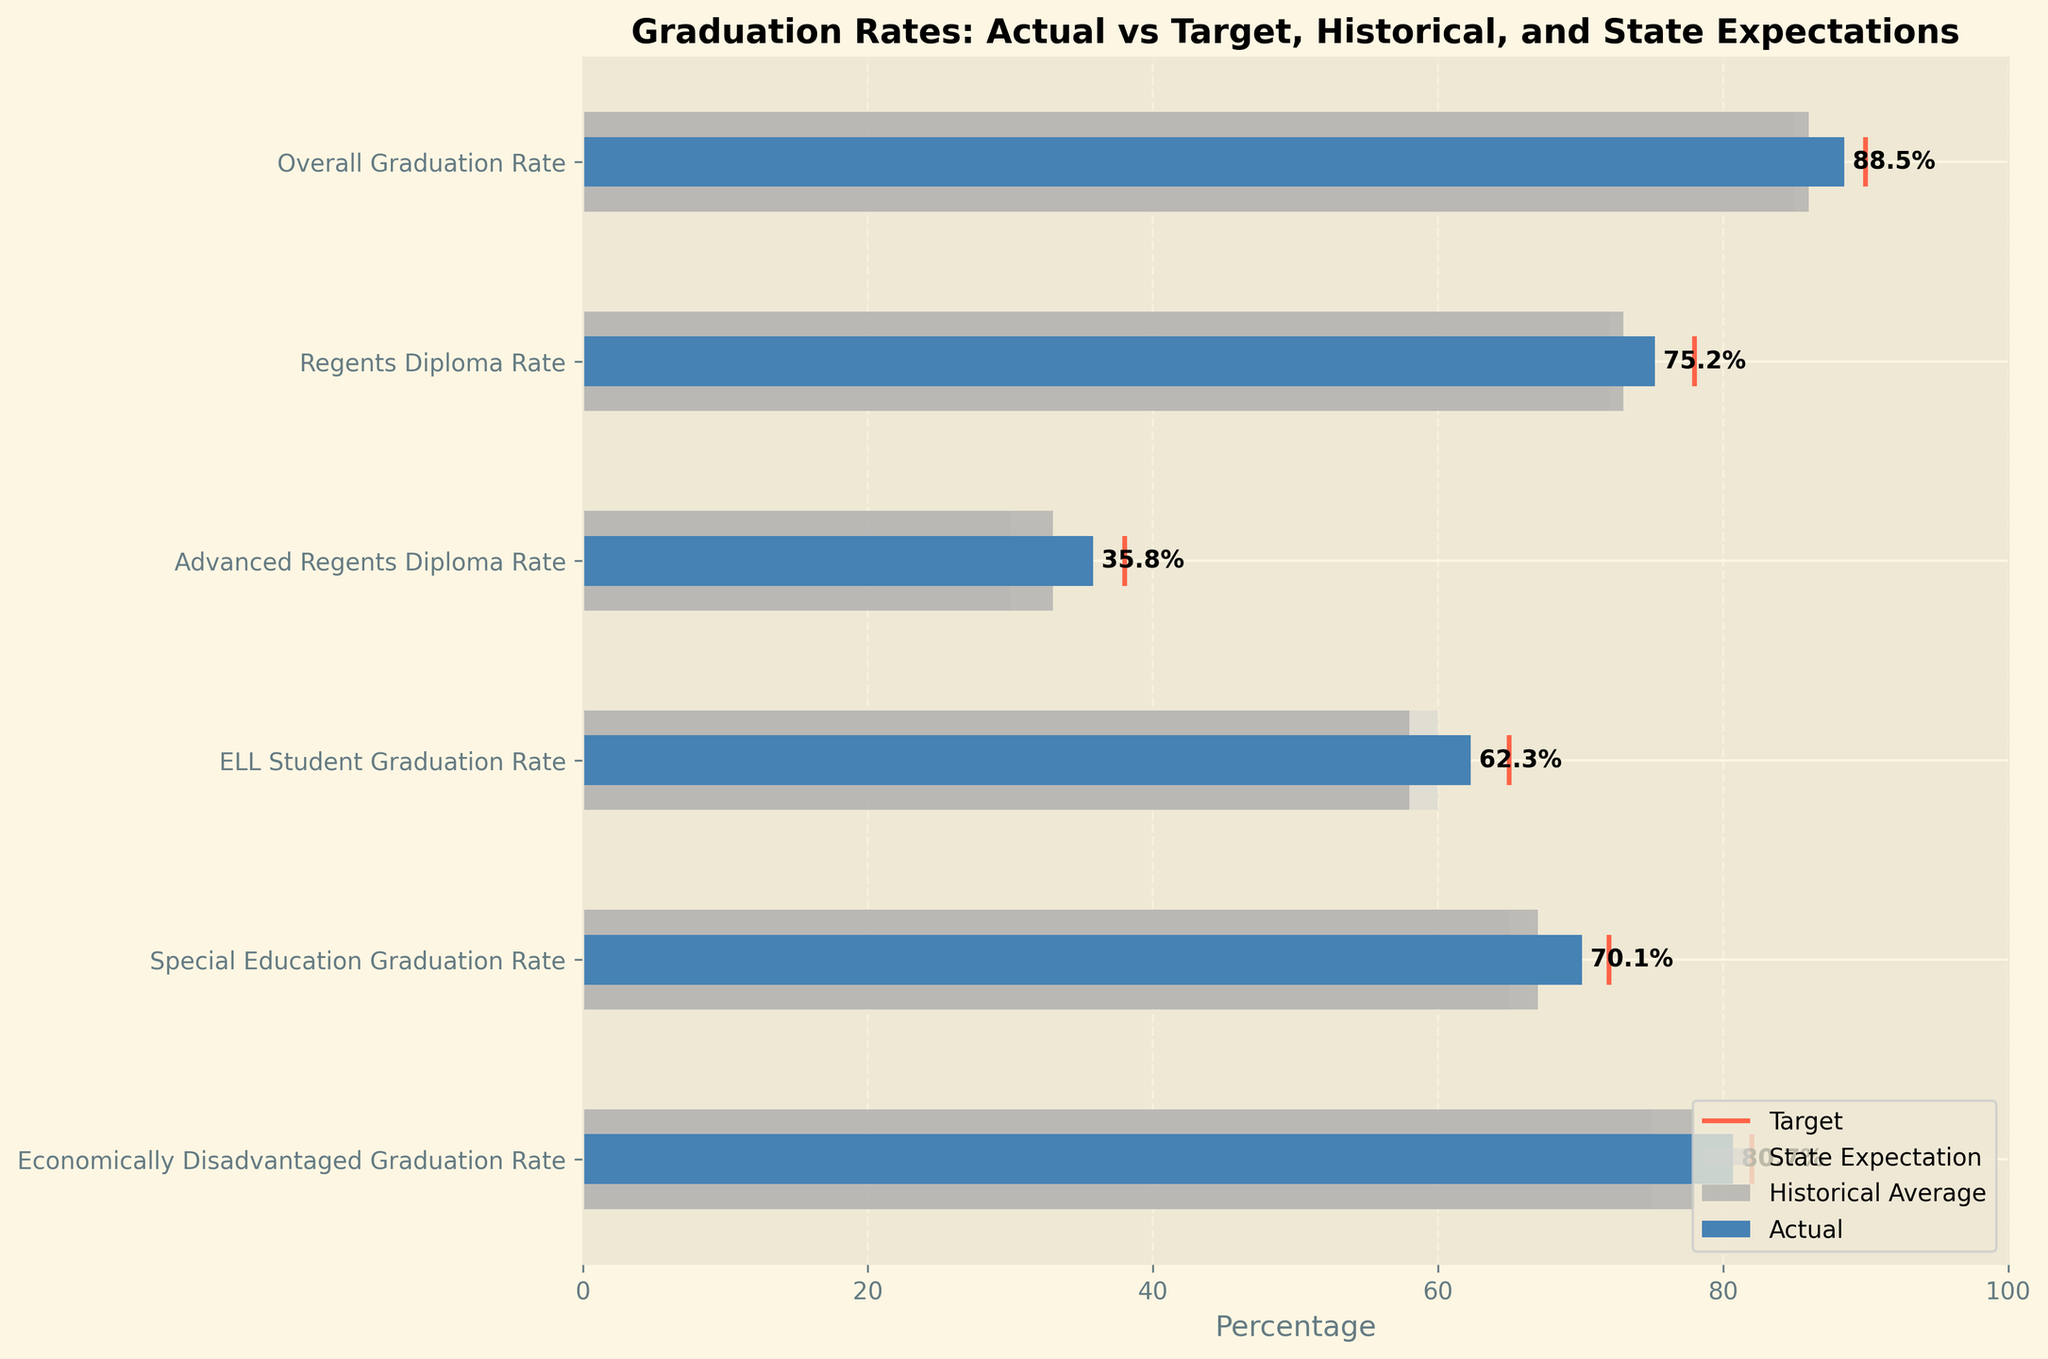How many categories are shown in the chart? The y-axis of the chart has labels corresponding to each category. By counting these labels, we find there are six categories listed.
Answer: Six What is the target for the Advanced Regents Diploma Rate? The thin, red vertical line indicates the target value for each category. For the Advanced Regents Diploma Rate, this line appears at the 38% mark.
Answer: 38% Which category has the lowest historical average graduation rate? By comparing the length of the gray bars representing the historical averages, the shortest bar corresponds to the ELL Student Graduation Rate at 58%.
Answer: ELL Student Graduation Rate How much higher is the actual graduation rate compared to the state expectation for Special Education students? The blue bar represents the actual value, and the light gray bar represents the state expectation. For Special Education students, the actual is 70.1%, and the state expectation is 65%. The difference is 70.1% - 65% = 5.1%.
Answer: 5.1% Which category has the largest gap between the historical average and the actual graduation rate? By measuring the length difference between the historical (dark gray) and actual (blue) bars for each category, the largest difference is seen in the ELL Student Graduation Rate (62.3% - 58% = 4.3%).
Answer: ELL Student Graduation Rate What is the title of the chart? The title is displayed at the top of the chart. It reads "Graduation Rates: Actual vs Target, Historical, and State Expectations".
Answer: Graduation Rates: Actual vs Target, Historical, and State Expectations Which category exceeds both its target and state expectation in its actual graduation rate? The blue bar (actual) must surpass both the red line (target) and the light gray bar (state expectation). This is true for the Overall Graduation Rate (88.5% > 90 and > 85).
Answer: Overall Graduation Rate What is the overall actual graduation rate in the district? The actual value for the Overall Graduation Rate category is shown by the blue bar at 88.5%.
Answer: 88.5% Between the Economically Disadvantaged Graduation Rate and the ELL Student Graduation Rate, which is closer to its target? The blue bar should be compared to the red line for each category. The Economically Disadvantaged Graduation Rate is 80.7% with a target of 82% (1.3% away), and the ELL Student Graduation Rate is 62.3% with a target of 65% (2.7% away). Thus, the Economically Disadvantaged Graduation Rate is closer to its target.
Answer: Economically Disadvantaged Graduation Rate 